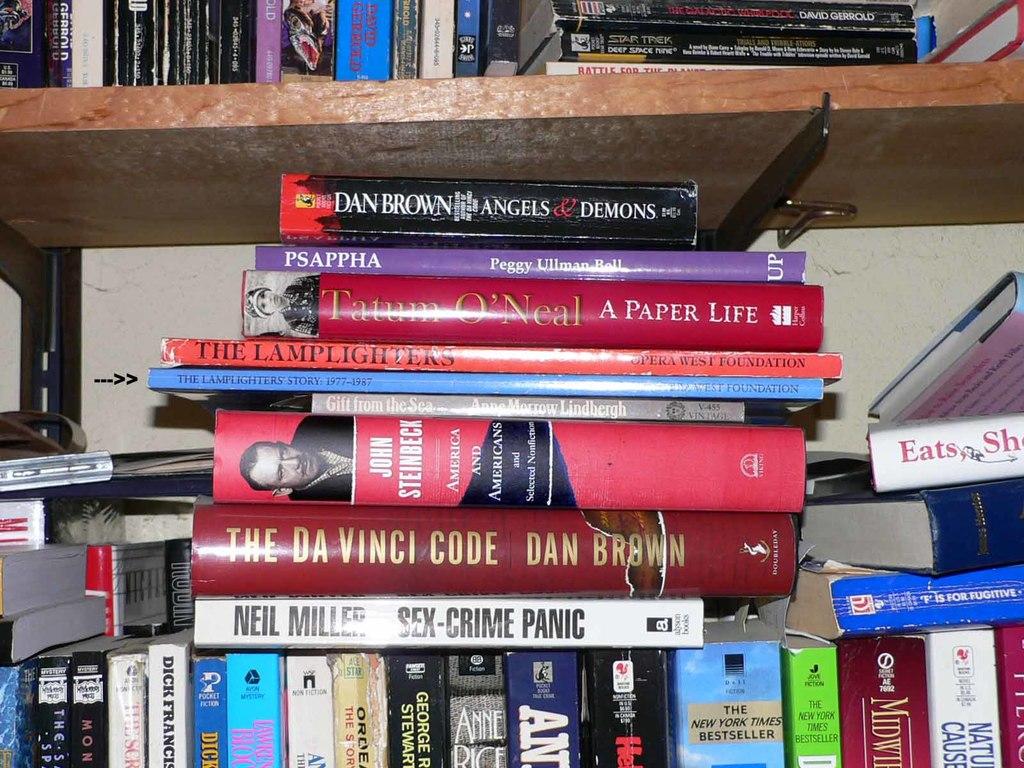Who wrote the da vinci code?
Your answer should be very brief. Dan brown. 